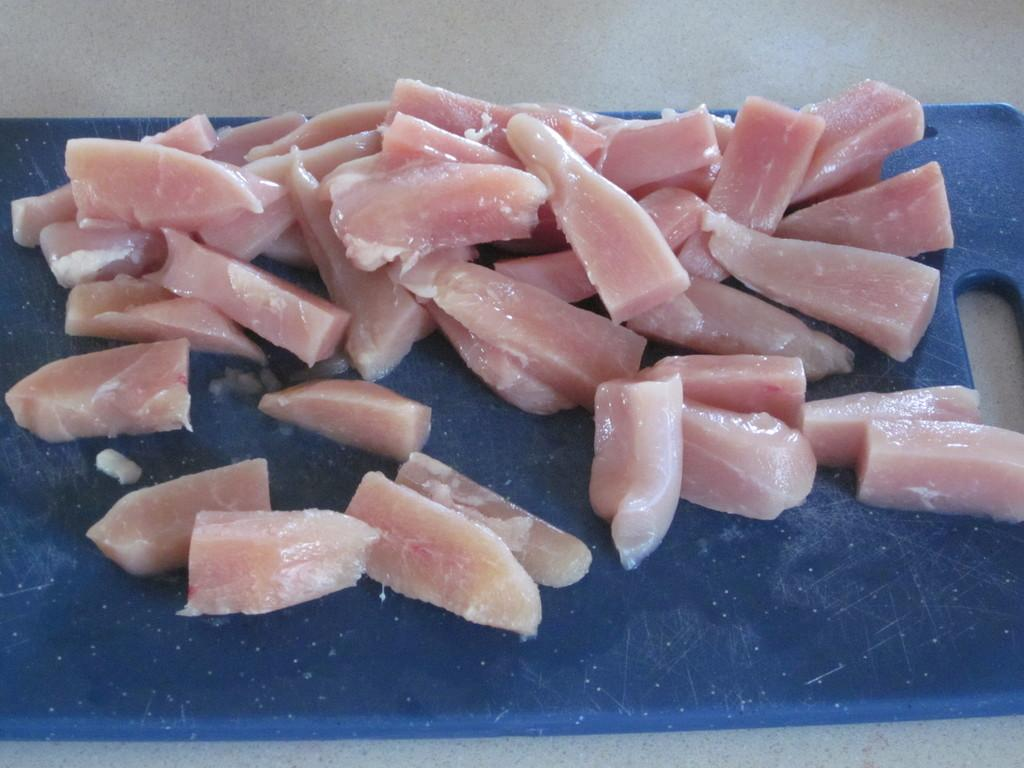What is present on the surface in the image? There is a cutting board in the image. Where is the cutting board located? The cutting board is on a surface in the image. What is on top of the cutting board? There are meat pieces on the cutting board. How many yaks are visible in the image? There are no yaks present in the image. What type of bone is being used to cut the meat in the image? There is no bone visible in the image; the meat is being cut with a knife or another cutting tool. 